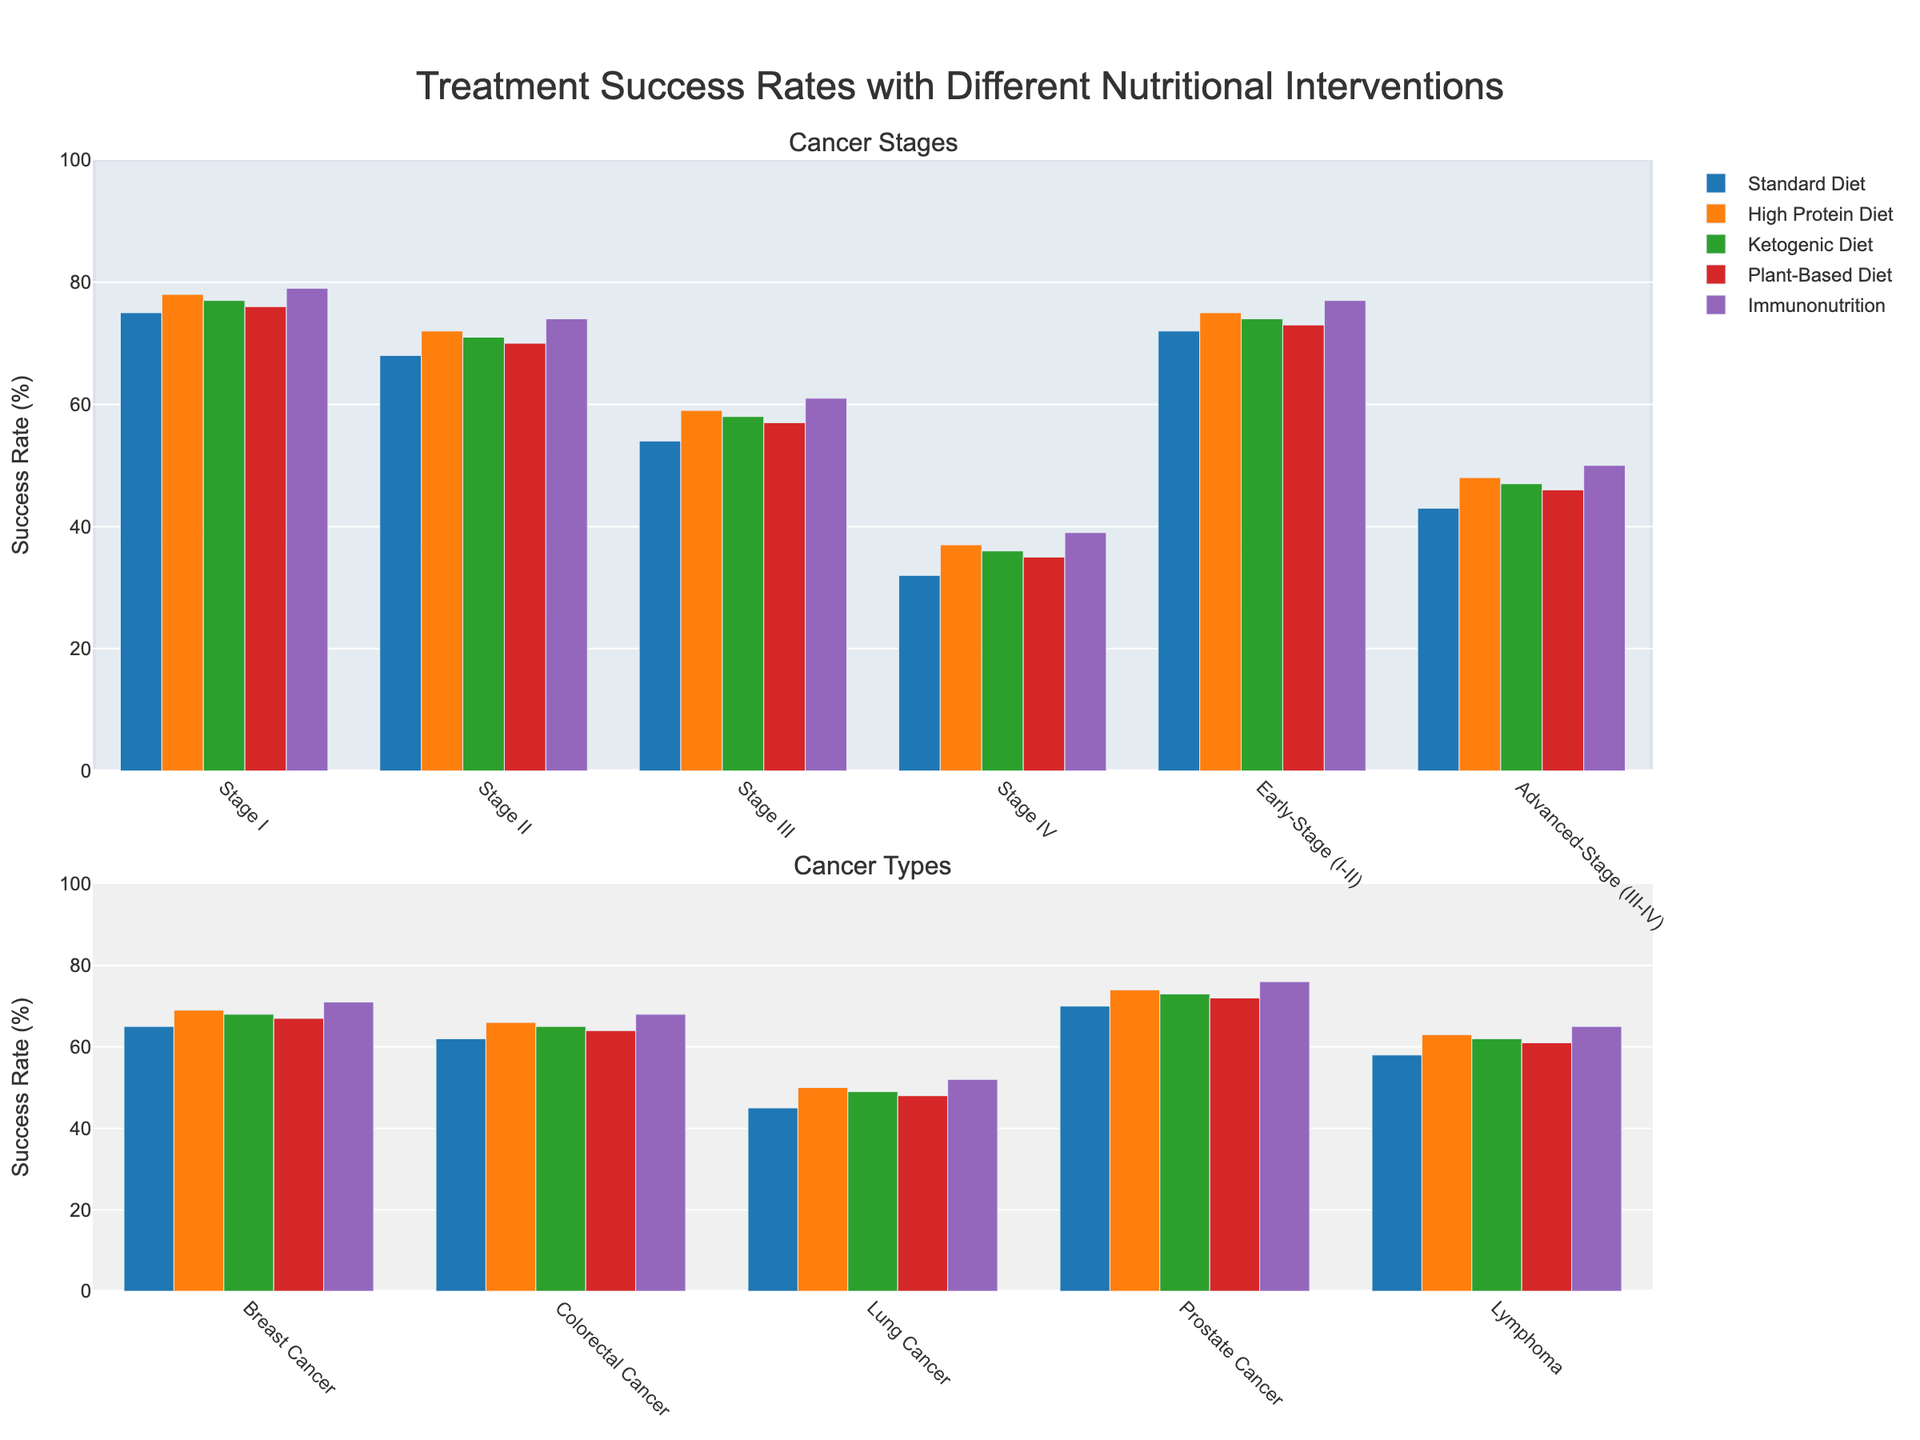What's the highest treatment success rate for Stage III cancer? The bar that represents Immunonutrition in Stage III cancer is the tallest among the bars corresponding to this group.
Answer: 61% Which cancer stage shows the most improvement in success rate when comparing Standard Diet to Immunonutrition? Subtract the success rates of Standard Diet from Immunonutrition for each stage and compare the differences. Stage IV shows the most significant improvement: 39% - 32% = 7%.
Answer: Stage IV Among the cancer types shown, which has the lowest success rate under the Ketogenic Diet? The shortest bar among the cancer types for the Ketogenic Diet corresponds to Lung Cancer.
Answer: Lung Cancer How does the treatment success rate for Plant-Based Diet in Early-Stage (I-II) compare to Advanced-Stage (III-IV)? Compare the bar heights: Early-Stage (I-II) has a success rate of 73%, and Advanced-Stage (III-IV) has 46% under the Plant-Based Diet.
Answer: Early-Stage (I-II) is higher Calculate the average success rate for High Protein Diet across all cancer stages. Sum the success rates of High Protein Diet across all stages: (78 + 72 + 59 + 37 + 75 + 48) = 369. Divide by the number of stages (6): 369 / 6 = 61.5%.
Answer: 61.5% What is the difference in success rates between Standard Diet and High Protein Diet for Colorectal Cancer? Compare the heights of the bars: 66% - 62% = 4%.
Answer: 4% Which nutritional intervention has the most consistent success rate across different cancer types? The length of the bars appears relatively consistent in height for Immunonutrition across different cancer types.
Answer: Immunonutrition Which treatment success rate for Prostate Cancer is equal to the success rate of Plant-Based Diet for Breast Cancer? Plant-Based Diet for Breast Cancer shows 67%, which is the same as the success rate for High Protein Diet in Prostate Cancer.
Answer: High Protein Diet How much higher is the success rate for Stage I cancer under Immunonutrition compared to Ketogenic Diet? Compare the bar heights: 79% - 77% = 2%.
Answer: 2% Is the success rate for Lung Cancer higher under the Standard Diet or the High Protein Diet? Compare the bars: High Protein Diet for Lung Cancer is 50%, which is higher than the Standard Diet at 45%.
Answer: High Protein Diet 